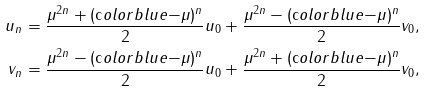Convert formula to latex. <formula><loc_0><loc_0><loc_500><loc_500>u _ { n } & = \frac { \mu ^ { 2 n } + ( \text  color{blue} { - } \mu ) ^ { n } } { 2 } u _ { 0 } + \frac { \mu ^ { 2 n } - ( \text  color{blue} { - } \mu ) ^ { n } } { 2 } v _ { 0 } , \\ v _ { n } & = \frac { \mu ^ { 2 n } - ( \text  color{blue} { - } \mu ) ^ { n } } { 2 } u _ { 0 } + \frac { \mu ^ { 2 n } + ( \text  color{blue} { - } \mu ) ^ { n } } { 2 } v _ { 0 } ,</formula> 